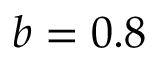Convert formula to latex. <formula><loc_0><loc_0><loc_500><loc_500>b = 0 . 8</formula> 